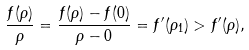<formula> <loc_0><loc_0><loc_500><loc_500>\frac { f ( \rho ) } { \rho } = \frac { f ( \rho ) - f ( 0 ) } { \rho - 0 } = f ^ { \prime } ( \rho _ { 1 } ) > f ^ { \prime } ( \rho ) ,</formula> 